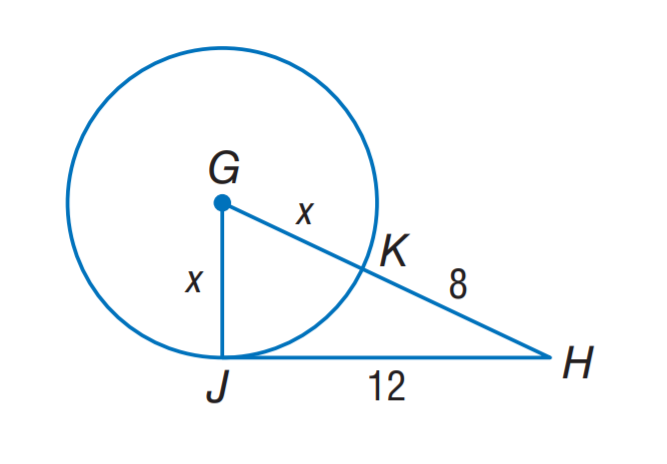Answer the mathemtical geometry problem and directly provide the correct option letter.
Question: J H is tangent to \odot G at J. Find the value of x.
Choices: A: 3 B: 5 C: 8 D: 12 B 